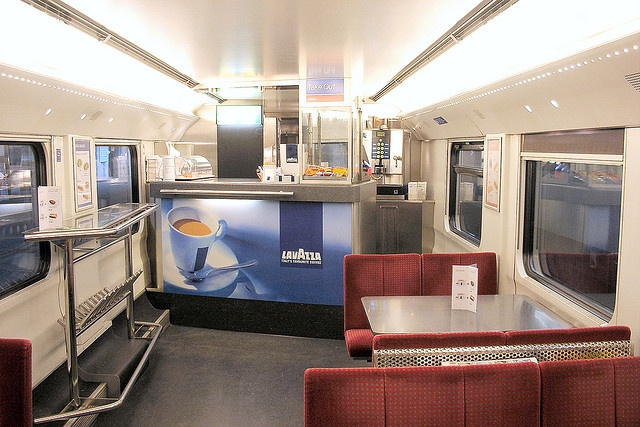Describe the objects in this image and their specific colors. I can see chair in white, maroon, brown, and black tones, dining table in white, darkgray, tan, and lightgray tones, chair in white, maroon, black, and brown tones, chair in white, maroon, brown, and black tones, and chair in white, maroon, ivory, gray, and black tones in this image. 